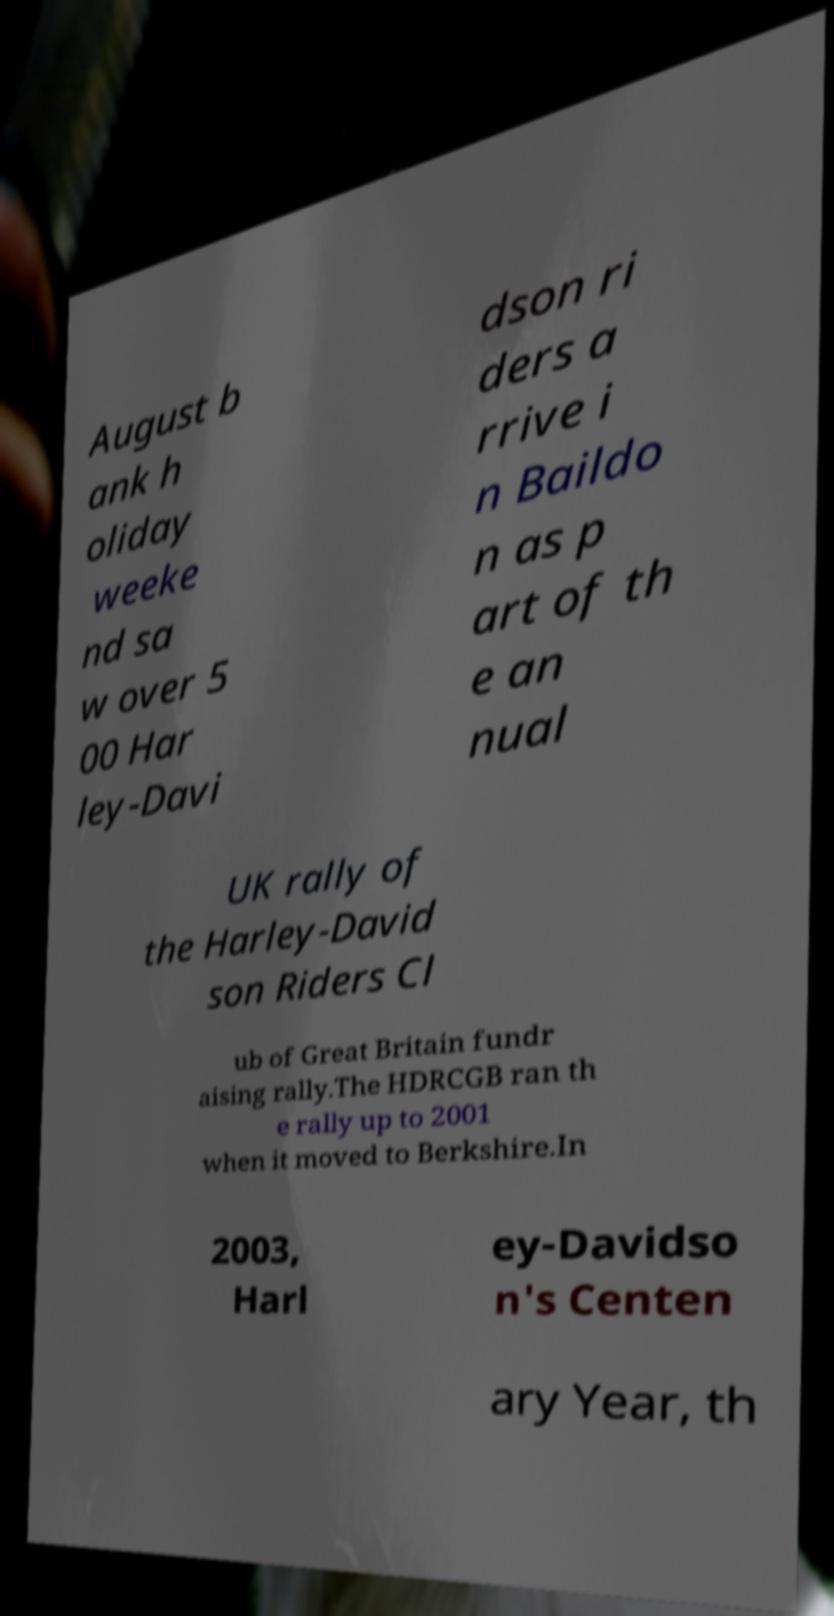There's text embedded in this image that I need extracted. Can you transcribe it verbatim? August b ank h oliday weeke nd sa w over 5 00 Har ley-Davi dson ri ders a rrive i n Baildo n as p art of th e an nual UK rally of the Harley-David son Riders Cl ub of Great Britain fundr aising rally.The HDRCGB ran th e rally up to 2001 when it moved to Berkshire.In 2003, Harl ey-Davidso n's Centen ary Year, th 